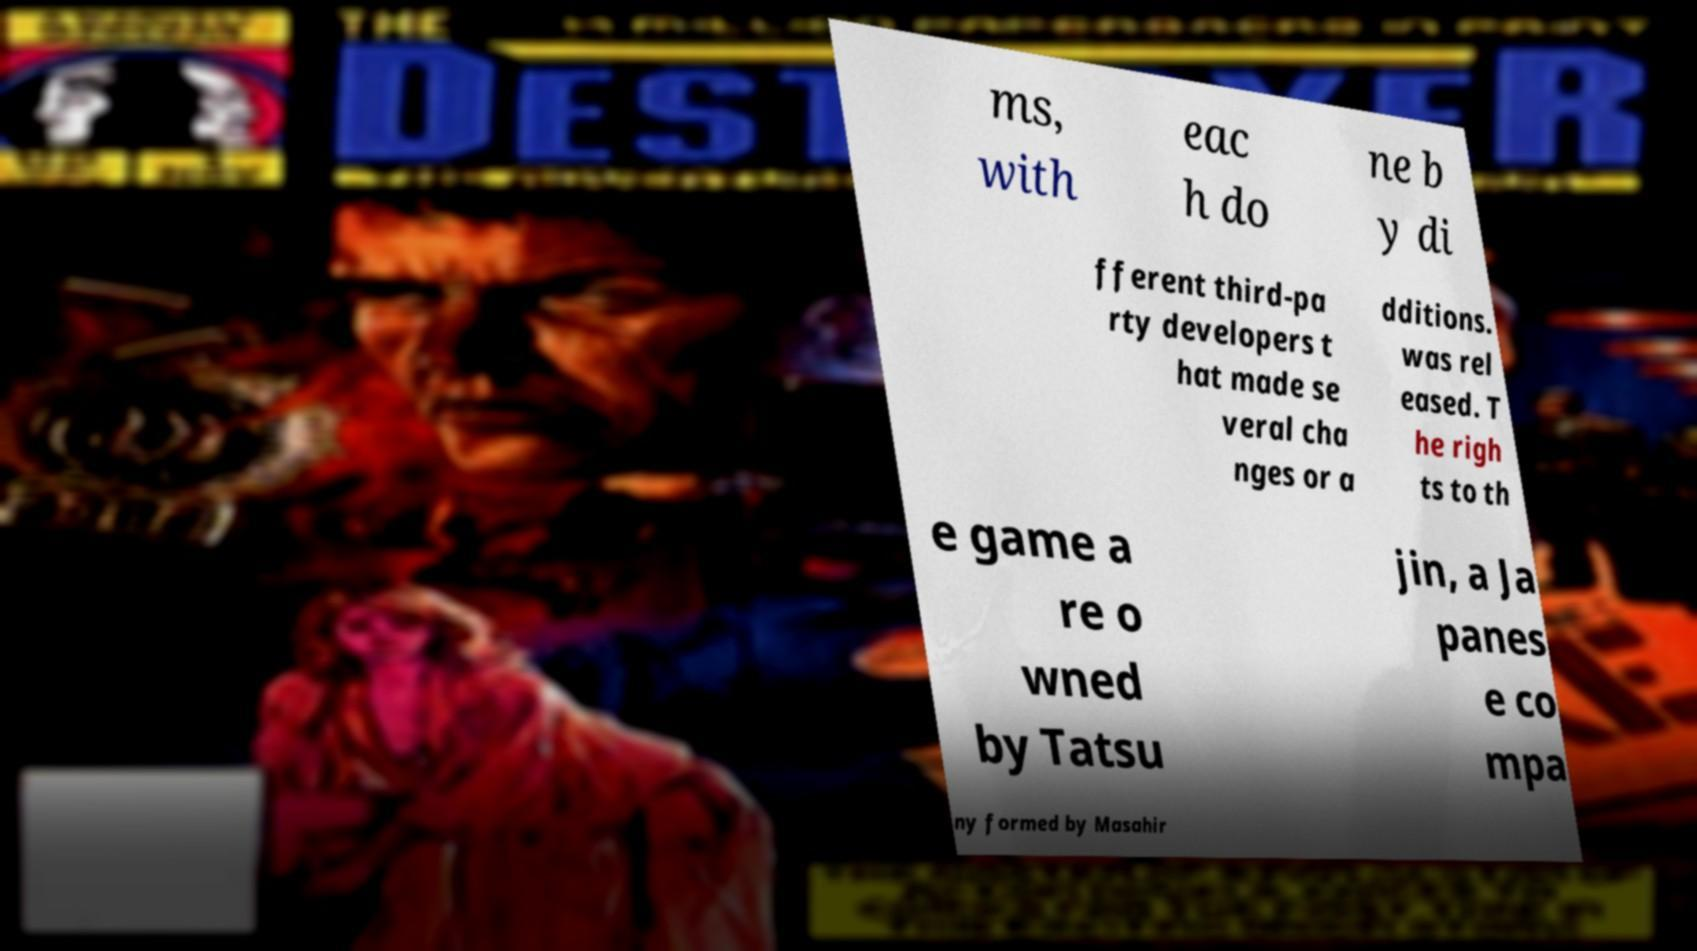I need the written content from this picture converted into text. Can you do that? ms, with eac h do ne b y di fferent third-pa rty developers t hat made se veral cha nges or a dditions. was rel eased. T he righ ts to th e game a re o wned by Tatsu jin, a Ja panes e co mpa ny formed by Masahir 